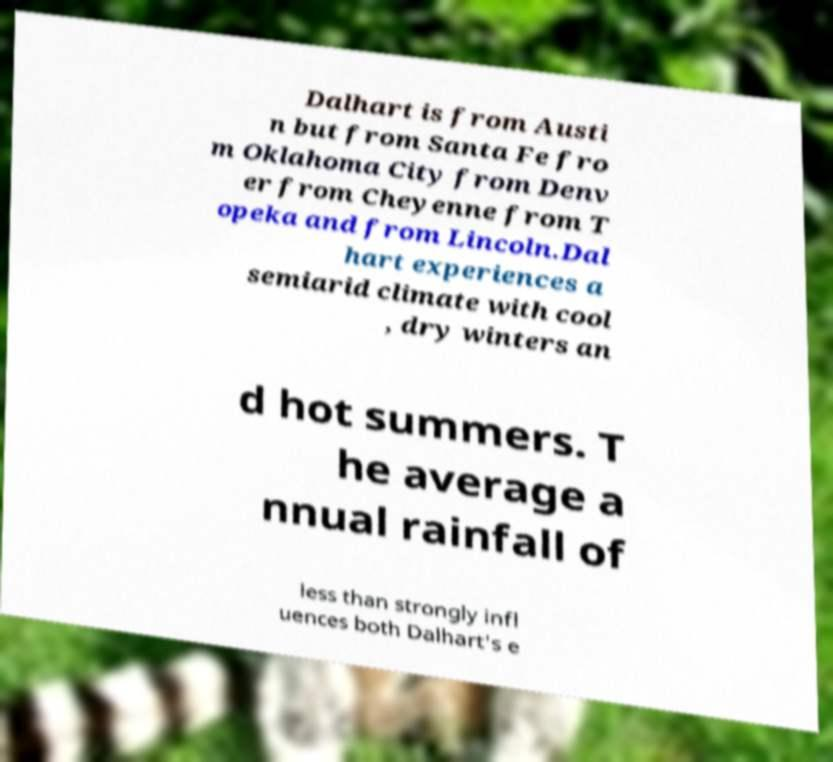I need the written content from this picture converted into text. Can you do that? Dalhart is from Austi n but from Santa Fe fro m Oklahoma City from Denv er from Cheyenne from T opeka and from Lincoln.Dal hart experiences a semiarid climate with cool , dry winters an d hot summers. T he average a nnual rainfall of less than strongly infl uences both Dalhart's e 